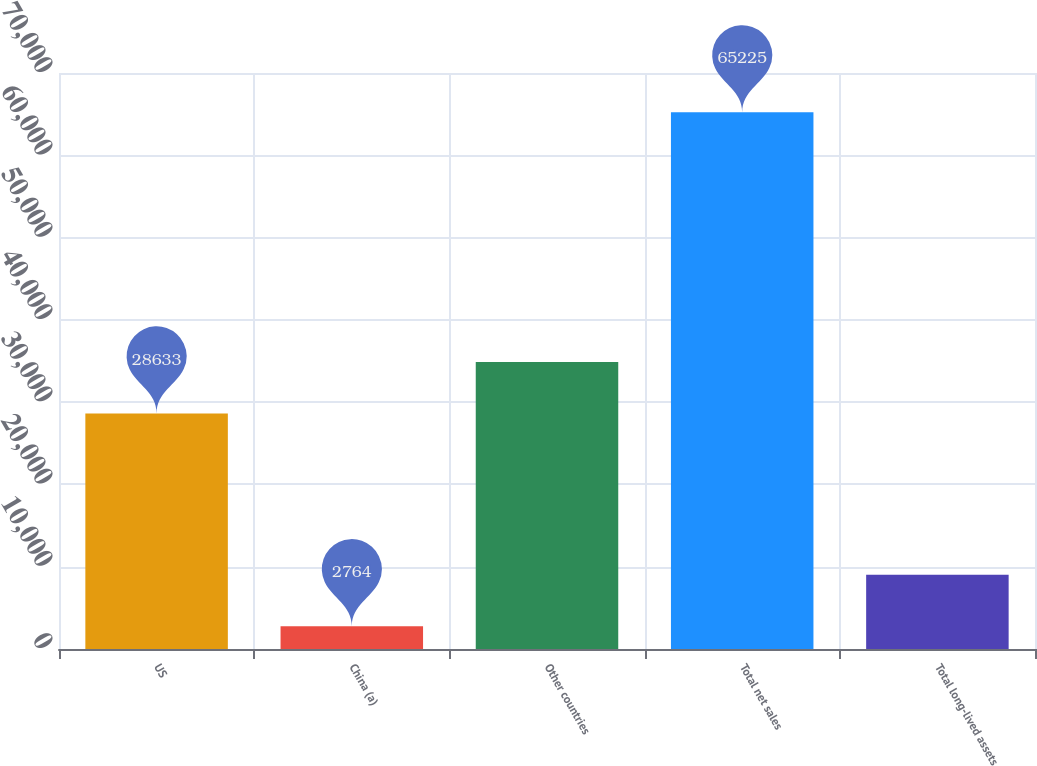<chart> <loc_0><loc_0><loc_500><loc_500><bar_chart><fcel>US<fcel>China (a)<fcel>Other countries<fcel>Total net sales<fcel>Total long-lived assets<nl><fcel>28633<fcel>2764<fcel>34879.1<fcel>65225<fcel>9010.1<nl></chart> 